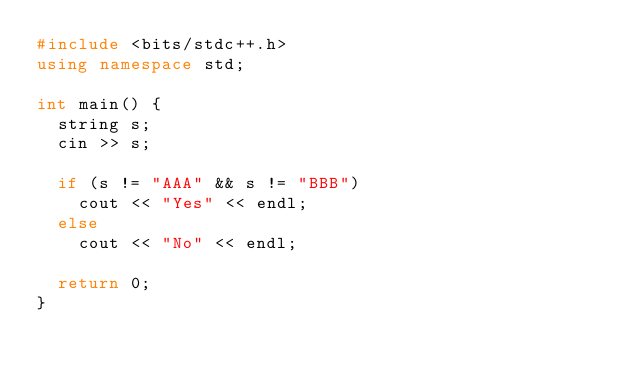Convert code to text. <code><loc_0><loc_0><loc_500><loc_500><_C++_>#include <bits/stdc++.h>
using namespace std;

int main() {
  string s;
  cin >> s;
  
  if (s != "AAA" && s != "BBB")
    cout << "Yes" << endl;
  else
    cout << "No" << endl;
  
  return 0;
}</code> 